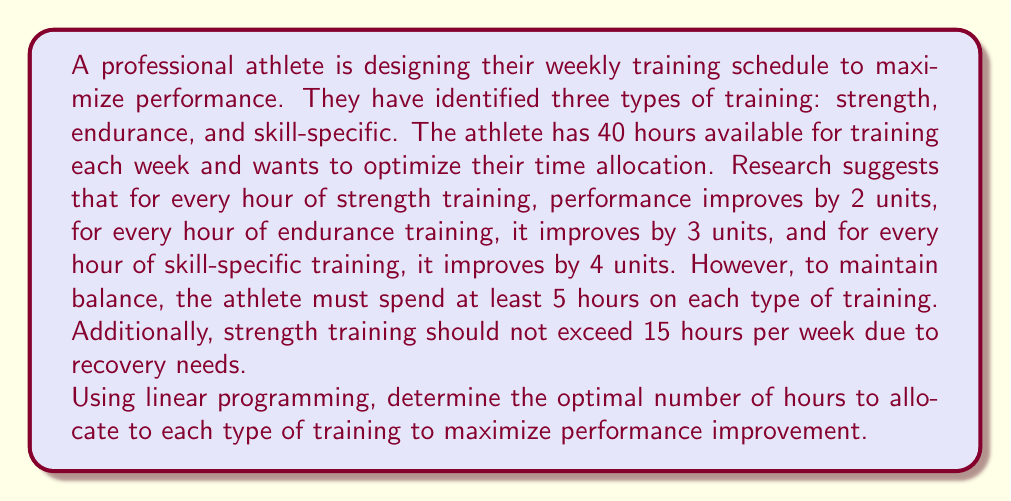Give your solution to this math problem. Let's approach this step-by-step using linear programming:

1) Define variables:
   Let $x$ = hours of strength training
   Let $y$ = hours of endurance training
   Let $z$ = hours of skill-specific training

2) Objective function:
   Maximize $2x + 3y + 4z$ (total performance improvement)

3) Constraints:
   a) Total time: $x + y + z \leq 40$
   b) Minimum time for each: $x \geq 5$, $y \geq 5$, $z \geq 5$
   c) Maximum strength training: $x \leq 15$
   d) Non-negativity: $x, y, z \geq 0$

4) Set up the linear program:

   Maximize: $2x + 3y + 4z$
   Subject to:
   $$\begin{align*}
   x + y + z &\leq 40 \\
   x &\geq 5 \\
   y &\geq 5 \\
   z &\geq 5 \\
   x &\leq 15 \\
   x, y, z &\geq 0
   \end{align*}$$

5) Solve using the simplex method or graphical method:
   The optimal solution is:
   $x = 15$ (strength training)
   $y = 5$ (endurance training)
   $z = 20$ (skill-specific training)

6) Verify the solution:
   - Total time: $15 + 5 + 20 = 40$ hours (meets the total time constraint)
   - All minimums are met (5 hours each)
   - Strength training maximum is met (15 hours)
   - Performance improvement: $2(15) + 3(5) + 4(20) = 30 + 15 + 80 = 125$ units

This solution maximizes the performance improvement while meeting all constraints.
Answer: Strength: 15 hours, Endurance: 5 hours, Skill-specific: 20 hours 